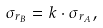Convert formula to latex. <formula><loc_0><loc_0><loc_500><loc_500>\sigma _ { r _ { B } } = k \cdot \sigma _ { r _ { A } } ,</formula> 